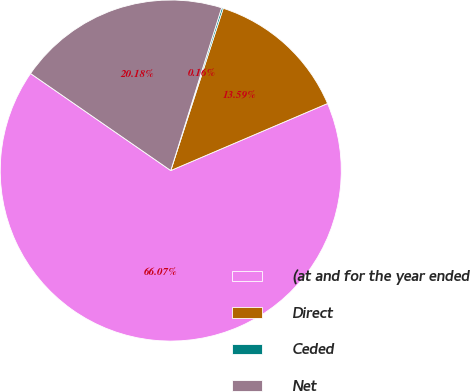<chart> <loc_0><loc_0><loc_500><loc_500><pie_chart><fcel>(at and for the year ended<fcel>Direct<fcel>Ceded<fcel>Net<nl><fcel>66.06%<fcel>13.59%<fcel>0.16%<fcel>20.18%<nl></chart> 